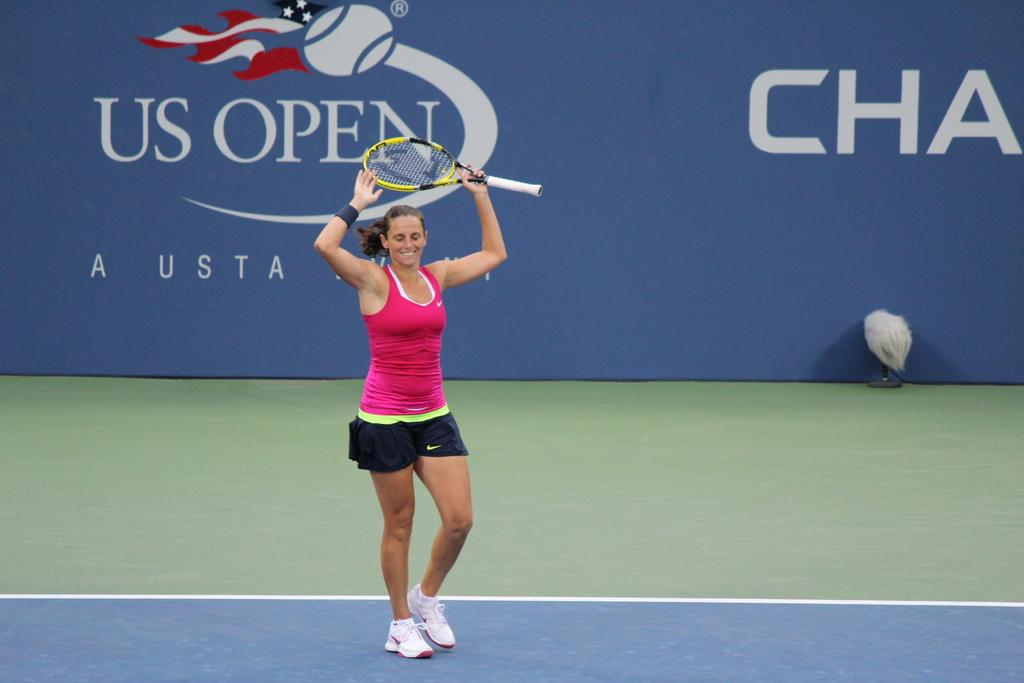What is the main setting of the image? The image depicts a tennis ground. Can you describe the person in the image? There is a woman in the image. What is the woman holding in her hand? The woman is holding a tennis bat in her left hand. What is the woman's facial expression? The woman is smiling. What color are the woman's shoes? The woman is wearing white color shoes. What can be seen in the background of the image? There is a blue color banner in the background of the image. What type of stove can be seen in the image? There is no stove present in the image; it depicts a tennis ground with a woman holding a tennis bat. 